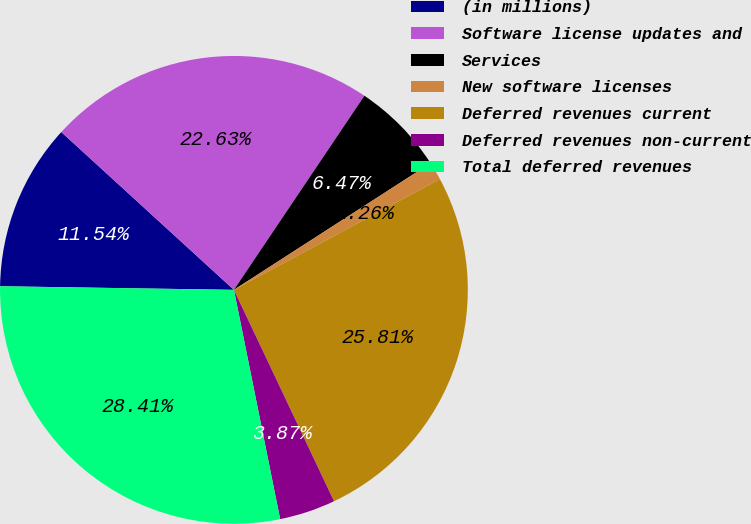Convert chart. <chart><loc_0><loc_0><loc_500><loc_500><pie_chart><fcel>(in millions)<fcel>Software license updates and<fcel>Services<fcel>New software licenses<fcel>Deferred revenues current<fcel>Deferred revenues non-current<fcel>Total deferred revenues<nl><fcel>11.54%<fcel>22.63%<fcel>6.47%<fcel>1.26%<fcel>25.81%<fcel>3.87%<fcel>28.41%<nl></chart> 